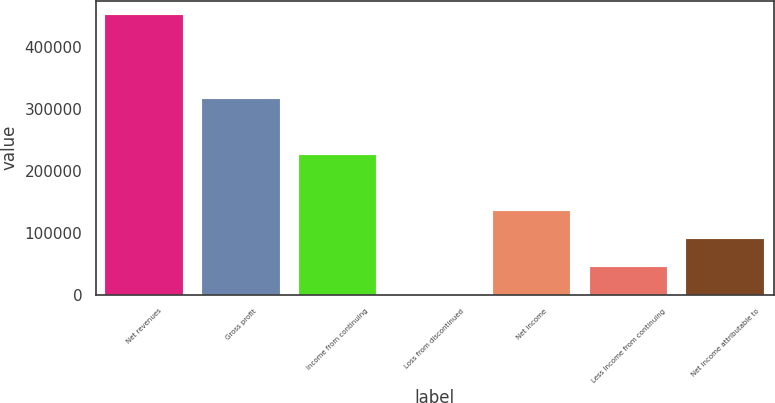<chart> <loc_0><loc_0><loc_500><loc_500><bar_chart><fcel>Net revenues<fcel>Gross profit<fcel>Income from continuing<fcel>Loss from discontinued<fcel>Net income<fcel>Less Income from continuing<fcel>Net income attributable to<nl><fcel>452045<fcel>316488<fcel>226118<fcel>190<fcel>135746<fcel>45375.5<fcel>90561<nl></chart> 